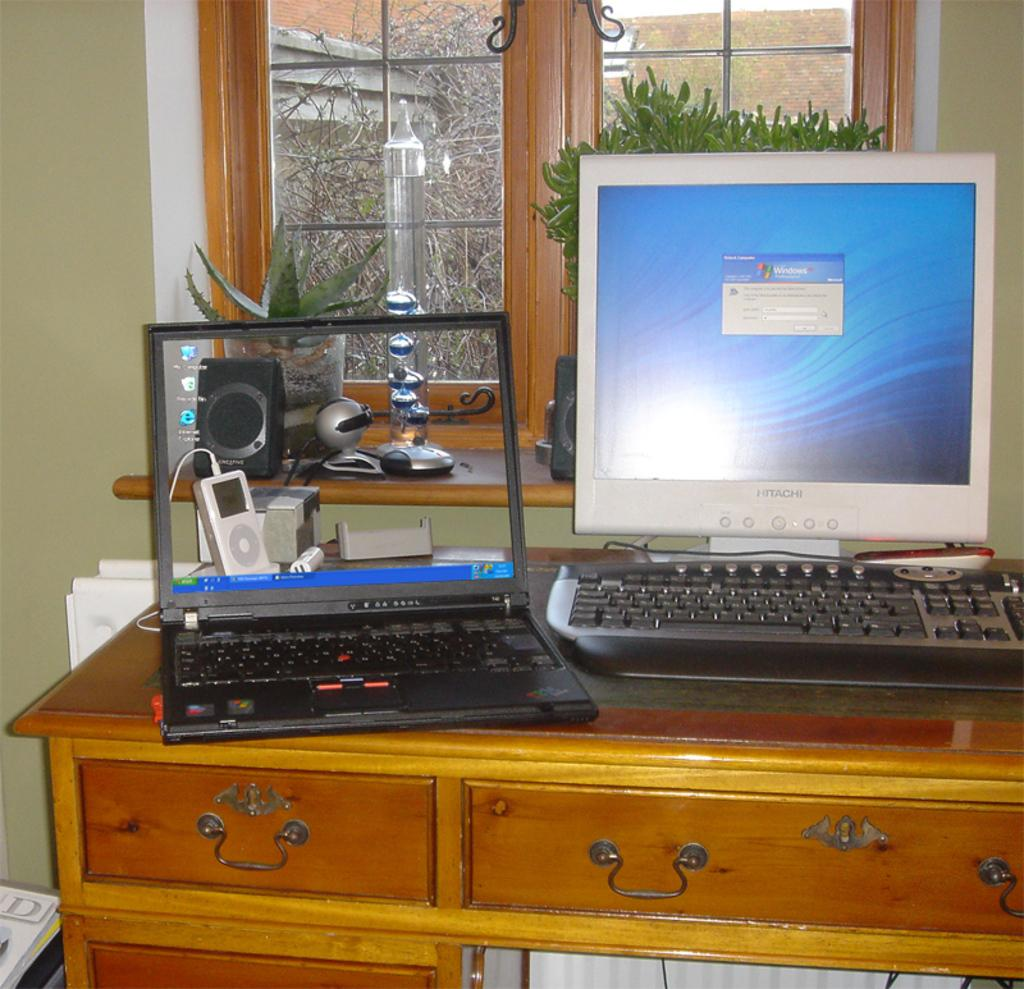What electronic devices can be seen in the image? There is a laptop and a desktop computer in the image. Where are the devices located? Both devices are on a table. What else can be seen in the background of the image? There are plants visible behind the devices. What type of card is being used by the spy in the image? There is no spy or card present in the image; it features a laptop and a desktop computer on a table with plants in the background. 